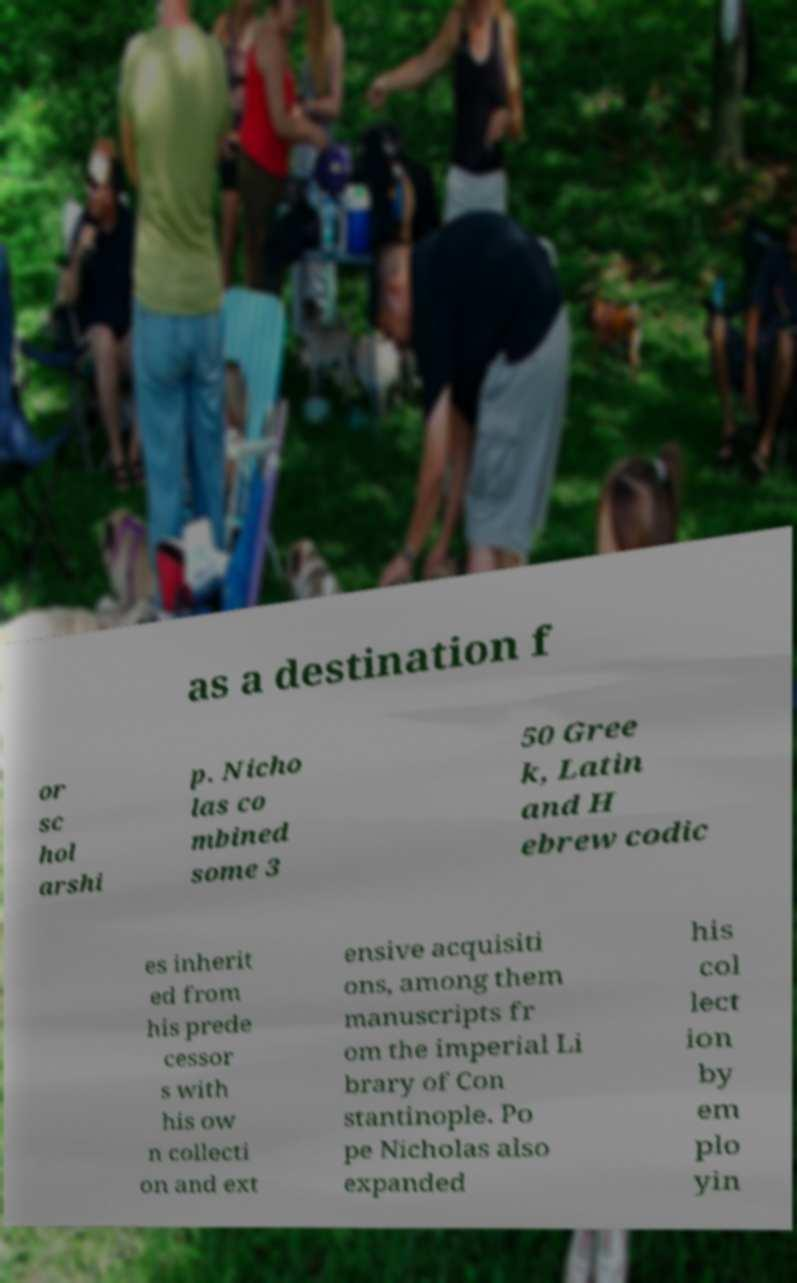What messages or text are displayed in this image? I need them in a readable, typed format. as a destination f or sc hol arshi p. Nicho las co mbined some 3 50 Gree k, Latin and H ebrew codic es inherit ed from his prede cessor s with his ow n collecti on and ext ensive acquisiti ons, among them manuscripts fr om the imperial Li brary of Con stantinople. Po pe Nicholas also expanded his col lect ion by em plo yin 